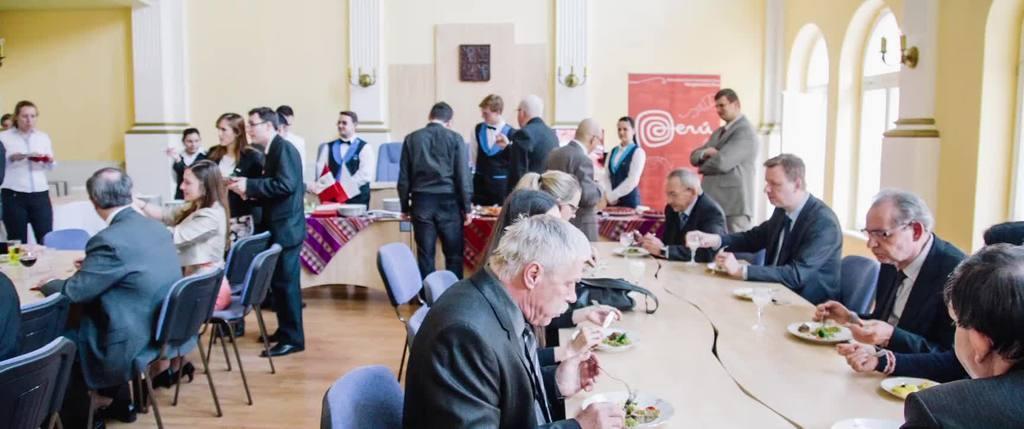Can you describe this image briefly? In the image we can see there are lot of people who are sitting on the chair and the other people are standing and on the table there are plate in which there are food item and a wine glass. 